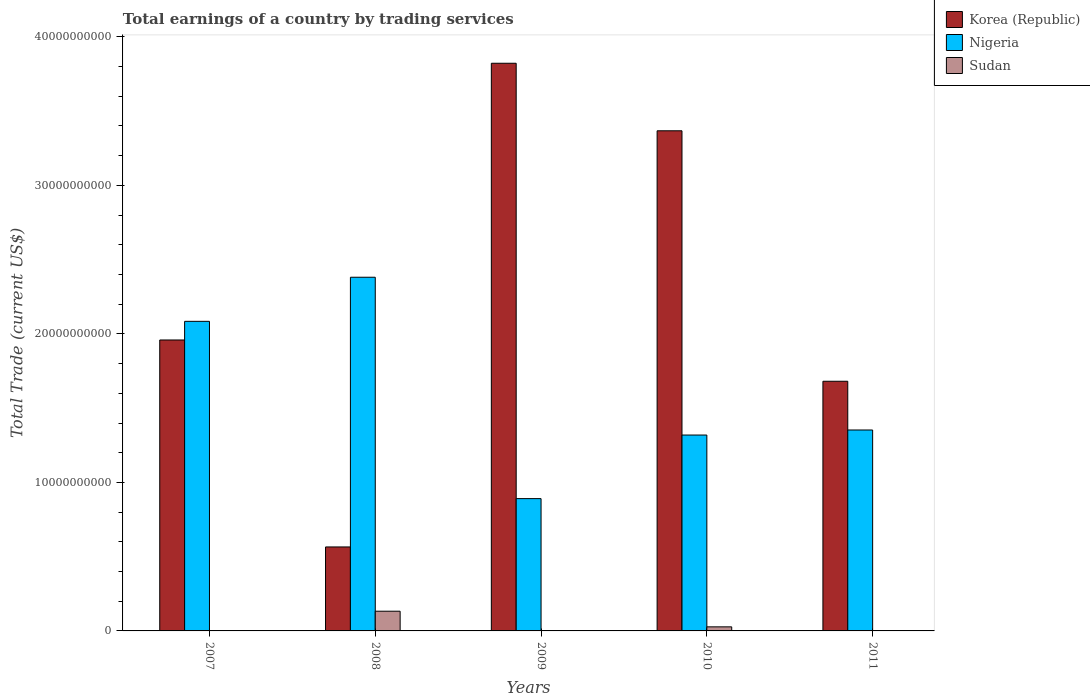How many groups of bars are there?
Your answer should be compact. 5. Are the number of bars on each tick of the X-axis equal?
Offer a terse response. No. How many bars are there on the 3rd tick from the left?
Your answer should be compact. 2. How many bars are there on the 1st tick from the right?
Your response must be concise. 3. In how many cases, is the number of bars for a given year not equal to the number of legend labels?
Your response must be concise. 2. What is the total earnings in Sudan in 2008?
Offer a very short reply. 1.33e+09. Across all years, what is the maximum total earnings in Nigeria?
Provide a short and direct response. 2.38e+1. Across all years, what is the minimum total earnings in Nigeria?
Make the answer very short. 8.91e+09. In which year was the total earnings in Korea (Republic) maximum?
Your response must be concise. 2009. What is the total total earnings in Nigeria in the graph?
Provide a succinct answer. 8.03e+1. What is the difference between the total earnings in Korea (Republic) in 2008 and that in 2010?
Offer a terse response. -2.80e+1. What is the difference between the total earnings in Nigeria in 2010 and the total earnings in Sudan in 2009?
Your response must be concise. 1.32e+1. What is the average total earnings in Sudan per year?
Your answer should be very brief. 3.25e+08. In the year 2008, what is the difference between the total earnings in Sudan and total earnings in Korea (Republic)?
Your answer should be compact. -4.33e+09. What is the ratio of the total earnings in Korea (Republic) in 2007 to that in 2008?
Your answer should be compact. 3.46. Is the total earnings in Sudan in 2008 less than that in 2010?
Give a very brief answer. No. Is the difference between the total earnings in Sudan in 2008 and 2010 greater than the difference between the total earnings in Korea (Republic) in 2008 and 2010?
Offer a terse response. Yes. What is the difference between the highest and the second highest total earnings in Korea (Republic)?
Your answer should be very brief. 4.55e+09. What is the difference between the highest and the lowest total earnings in Sudan?
Your answer should be very brief. 1.33e+09. In how many years, is the total earnings in Sudan greater than the average total earnings in Sudan taken over all years?
Provide a succinct answer. 1. Is the sum of the total earnings in Korea (Republic) in 2008 and 2009 greater than the maximum total earnings in Sudan across all years?
Offer a terse response. Yes. Is it the case that in every year, the sum of the total earnings in Sudan and total earnings in Nigeria is greater than the total earnings in Korea (Republic)?
Your response must be concise. No. Are all the bars in the graph horizontal?
Provide a short and direct response. No. How many years are there in the graph?
Ensure brevity in your answer.  5. What is the difference between two consecutive major ticks on the Y-axis?
Offer a terse response. 1.00e+1. Are the values on the major ticks of Y-axis written in scientific E-notation?
Offer a very short reply. No. Does the graph contain any zero values?
Your answer should be very brief. Yes. What is the title of the graph?
Make the answer very short. Total earnings of a country by trading services. What is the label or title of the X-axis?
Provide a succinct answer. Years. What is the label or title of the Y-axis?
Provide a short and direct response. Total Trade (current US$). What is the Total Trade (current US$) of Korea (Republic) in 2007?
Your response must be concise. 1.96e+1. What is the Total Trade (current US$) of Nigeria in 2007?
Your answer should be very brief. 2.08e+1. What is the Total Trade (current US$) of Korea (Republic) in 2008?
Offer a terse response. 5.65e+09. What is the Total Trade (current US$) in Nigeria in 2008?
Offer a terse response. 2.38e+1. What is the Total Trade (current US$) of Sudan in 2008?
Your response must be concise. 1.33e+09. What is the Total Trade (current US$) of Korea (Republic) in 2009?
Ensure brevity in your answer.  3.82e+1. What is the Total Trade (current US$) in Nigeria in 2009?
Offer a very short reply. 8.91e+09. What is the Total Trade (current US$) of Korea (Republic) in 2010?
Give a very brief answer. 3.37e+1. What is the Total Trade (current US$) in Nigeria in 2010?
Offer a very short reply. 1.32e+1. What is the Total Trade (current US$) in Sudan in 2010?
Provide a short and direct response. 2.74e+08. What is the Total Trade (current US$) in Korea (Republic) in 2011?
Give a very brief answer. 1.68e+1. What is the Total Trade (current US$) of Nigeria in 2011?
Your answer should be very brief. 1.35e+1. What is the Total Trade (current US$) in Sudan in 2011?
Offer a very short reply. 2.31e+07. Across all years, what is the maximum Total Trade (current US$) of Korea (Republic)?
Ensure brevity in your answer.  3.82e+1. Across all years, what is the maximum Total Trade (current US$) of Nigeria?
Ensure brevity in your answer.  2.38e+1. Across all years, what is the maximum Total Trade (current US$) in Sudan?
Provide a short and direct response. 1.33e+09. Across all years, what is the minimum Total Trade (current US$) of Korea (Republic)?
Provide a short and direct response. 5.65e+09. Across all years, what is the minimum Total Trade (current US$) of Nigeria?
Your answer should be compact. 8.91e+09. What is the total Total Trade (current US$) in Korea (Republic) in the graph?
Ensure brevity in your answer.  1.14e+11. What is the total Total Trade (current US$) of Nigeria in the graph?
Your answer should be very brief. 8.03e+1. What is the total Total Trade (current US$) of Sudan in the graph?
Keep it short and to the point. 1.62e+09. What is the difference between the Total Trade (current US$) of Korea (Republic) in 2007 and that in 2008?
Offer a very short reply. 1.39e+1. What is the difference between the Total Trade (current US$) of Nigeria in 2007 and that in 2008?
Provide a succinct answer. -2.97e+09. What is the difference between the Total Trade (current US$) in Korea (Republic) in 2007 and that in 2009?
Provide a short and direct response. -1.86e+1. What is the difference between the Total Trade (current US$) in Nigeria in 2007 and that in 2009?
Your response must be concise. 1.19e+1. What is the difference between the Total Trade (current US$) of Korea (Republic) in 2007 and that in 2010?
Your answer should be very brief. -1.41e+1. What is the difference between the Total Trade (current US$) of Nigeria in 2007 and that in 2010?
Make the answer very short. 7.66e+09. What is the difference between the Total Trade (current US$) of Korea (Republic) in 2007 and that in 2011?
Provide a short and direct response. 2.78e+09. What is the difference between the Total Trade (current US$) in Nigeria in 2007 and that in 2011?
Your answer should be very brief. 7.32e+09. What is the difference between the Total Trade (current US$) in Korea (Republic) in 2008 and that in 2009?
Your answer should be compact. -3.26e+1. What is the difference between the Total Trade (current US$) in Nigeria in 2008 and that in 2009?
Your response must be concise. 1.49e+1. What is the difference between the Total Trade (current US$) of Korea (Republic) in 2008 and that in 2010?
Your answer should be compact. -2.80e+1. What is the difference between the Total Trade (current US$) of Nigeria in 2008 and that in 2010?
Give a very brief answer. 1.06e+1. What is the difference between the Total Trade (current US$) in Sudan in 2008 and that in 2010?
Your response must be concise. 1.05e+09. What is the difference between the Total Trade (current US$) in Korea (Republic) in 2008 and that in 2011?
Make the answer very short. -1.12e+1. What is the difference between the Total Trade (current US$) of Nigeria in 2008 and that in 2011?
Offer a very short reply. 1.03e+1. What is the difference between the Total Trade (current US$) of Sudan in 2008 and that in 2011?
Offer a terse response. 1.30e+09. What is the difference between the Total Trade (current US$) of Korea (Republic) in 2009 and that in 2010?
Offer a very short reply. 4.55e+09. What is the difference between the Total Trade (current US$) of Nigeria in 2009 and that in 2010?
Your response must be concise. -4.28e+09. What is the difference between the Total Trade (current US$) in Korea (Republic) in 2009 and that in 2011?
Your answer should be compact. 2.14e+1. What is the difference between the Total Trade (current US$) of Nigeria in 2009 and that in 2011?
Your answer should be compact. -4.62e+09. What is the difference between the Total Trade (current US$) of Korea (Republic) in 2010 and that in 2011?
Keep it short and to the point. 1.69e+1. What is the difference between the Total Trade (current US$) of Nigeria in 2010 and that in 2011?
Offer a terse response. -3.40e+08. What is the difference between the Total Trade (current US$) of Sudan in 2010 and that in 2011?
Provide a succinct answer. 2.51e+08. What is the difference between the Total Trade (current US$) of Korea (Republic) in 2007 and the Total Trade (current US$) of Nigeria in 2008?
Give a very brief answer. -4.22e+09. What is the difference between the Total Trade (current US$) of Korea (Republic) in 2007 and the Total Trade (current US$) of Sudan in 2008?
Your answer should be very brief. 1.83e+1. What is the difference between the Total Trade (current US$) in Nigeria in 2007 and the Total Trade (current US$) in Sudan in 2008?
Provide a short and direct response. 1.95e+1. What is the difference between the Total Trade (current US$) of Korea (Republic) in 2007 and the Total Trade (current US$) of Nigeria in 2009?
Give a very brief answer. 1.07e+1. What is the difference between the Total Trade (current US$) of Korea (Republic) in 2007 and the Total Trade (current US$) of Nigeria in 2010?
Offer a terse response. 6.40e+09. What is the difference between the Total Trade (current US$) of Korea (Republic) in 2007 and the Total Trade (current US$) of Sudan in 2010?
Your answer should be compact. 1.93e+1. What is the difference between the Total Trade (current US$) in Nigeria in 2007 and the Total Trade (current US$) in Sudan in 2010?
Ensure brevity in your answer.  2.06e+1. What is the difference between the Total Trade (current US$) of Korea (Republic) in 2007 and the Total Trade (current US$) of Nigeria in 2011?
Keep it short and to the point. 6.06e+09. What is the difference between the Total Trade (current US$) of Korea (Republic) in 2007 and the Total Trade (current US$) of Sudan in 2011?
Make the answer very short. 1.96e+1. What is the difference between the Total Trade (current US$) in Nigeria in 2007 and the Total Trade (current US$) in Sudan in 2011?
Keep it short and to the point. 2.08e+1. What is the difference between the Total Trade (current US$) of Korea (Republic) in 2008 and the Total Trade (current US$) of Nigeria in 2009?
Ensure brevity in your answer.  -3.25e+09. What is the difference between the Total Trade (current US$) in Korea (Republic) in 2008 and the Total Trade (current US$) in Nigeria in 2010?
Provide a short and direct response. -7.53e+09. What is the difference between the Total Trade (current US$) of Korea (Republic) in 2008 and the Total Trade (current US$) of Sudan in 2010?
Give a very brief answer. 5.38e+09. What is the difference between the Total Trade (current US$) in Nigeria in 2008 and the Total Trade (current US$) in Sudan in 2010?
Your answer should be compact. 2.35e+1. What is the difference between the Total Trade (current US$) of Korea (Republic) in 2008 and the Total Trade (current US$) of Nigeria in 2011?
Make the answer very short. -7.88e+09. What is the difference between the Total Trade (current US$) of Korea (Republic) in 2008 and the Total Trade (current US$) of Sudan in 2011?
Give a very brief answer. 5.63e+09. What is the difference between the Total Trade (current US$) of Nigeria in 2008 and the Total Trade (current US$) of Sudan in 2011?
Offer a terse response. 2.38e+1. What is the difference between the Total Trade (current US$) in Korea (Republic) in 2009 and the Total Trade (current US$) in Nigeria in 2010?
Make the answer very short. 2.50e+1. What is the difference between the Total Trade (current US$) in Korea (Republic) in 2009 and the Total Trade (current US$) in Sudan in 2010?
Provide a short and direct response. 3.79e+1. What is the difference between the Total Trade (current US$) in Nigeria in 2009 and the Total Trade (current US$) in Sudan in 2010?
Keep it short and to the point. 8.63e+09. What is the difference between the Total Trade (current US$) in Korea (Republic) in 2009 and the Total Trade (current US$) in Nigeria in 2011?
Give a very brief answer. 2.47e+1. What is the difference between the Total Trade (current US$) of Korea (Republic) in 2009 and the Total Trade (current US$) of Sudan in 2011?
Your answer should be compact. 3.82e+1. What is the difference between the Total Trade (current US$) of Nigeria in 2009 and the Total Trade (current US$) of Sudan in 2011?
Your response must be concise. 8.89e+09. What is the difference between the Total Trade (current US$) of Korea (Republic) in 2010 and the Total Trade (current US$) of Nigeria in 2011?
Your answer should be very brief. 2.01e+1. What is the difference between the Total Trade (current US$) of Korea (Republic) in 2010 and the Total Trade (current US$) of Sudan in 2011?
Your answer should be compact. 3.37e+1. What is the difference between the Total Trade (current US$) of Nigeria in 2010 and the Total Trade (current US$) of Sudan in 2011?
Ensure brevity in your answer.  1.32e+1. What is the average Total Trade (current US$) of Korea (Republic) per year?
Give a very brief answer. 2.28e+1. What is the average Total Trade (current US$) in Nigeria per year?
Give a very brief answer. 1.61e+1. What is the average Total Trade (current US$) in Sudan per year?
Keep it short and to the point. 3.25e+08. In the year 2007, what is the difference between the Total Trade (current US$) of Korea (Republic) and Total Trade (current US$) of Nigeria?
Make the answer very short. -1.26e+09. In the year 2008, what is the difference between the Total Trade (current US$) in Korea (Republic) and Total Trade (current US$) in Nigeria?
Provide a succinct answer. -1.82e+1. In the year 2008, what is the difference between the Total Trade (current US$) in Korea (Republic) and Total Trade (current US$) in Sudan?
Keep it short and to the point. 4.33e+09. In the year 2008, what is the difference between the Total Trade (current US$) in Nigeria and Total Trade (current US$) in Sudan?
Your response must be concise. 2.25e+1. In the year 2009, what is the difference between the Total Trade (current US$) of Korea (Republic) and Total Trade (current US$) of Nigeria?
Give a very brief answer. 2.93e+1. In the year 2010, what is the difference between the Total Trade (current US$) in Korea (Republic) and Total Trade (current US$) in Nigeria?
Your answer should be compact. 2.05e+1. In the year 2010, what is the difference between the Total Trade (current US$) of Korea (Republic) and Total Trade (current US$) of Sudan?
Your answer should be compact. 3.34e+1. In the year 2010, what is the difference between the Total Trade (current US$) in Nigeria and Total Trade (current US$) in Sudan?
Ensure brevity in your answer.  1.29e+1. In the year 2011, what is the difference between the Total Trade (current US$) of Korea (Republic) and Total Trade (current US$) of Nigeria?
Ensure brevity in your answer.  3.28e+09. In the year 2011, what is the difference between the Total Trade (current US$) of Korea (Republic) and Total Trade (current US$) of Sudan?
Ensure brevity in your answer.  1.68e+1. In the year 2011, what is the difference between the Total Trade (current US$) in Nigeria and Total Trade (current US$) in Sudan?
Your answer should be compact. 1.35e+1. What is the ratio of the Total Trade (current US$) in Korea (Republic) in 2007 to that in 2008?
Offer a terse response. 3.46. What is the ratio of the Total Trade (current US$) of Nigeria in 2007 to that in 2008?
Keep it short and to the point. 0.88. What is the ratio of the Total Trade (current US$) of Korea (Republic) in 2007 to that in 2009?
Provide a short and direct response. 0.51. What is the ratio of the Total Trade (current US$) of Nigeria in 2007 to that in 2009?
Your response must be concise. 2.34. What is the ratio of the Total Trade (current US$) of Korea (Republic) in 2007 to that in 2010?
Make the answer very short. 0.58. What is the ratio of the Total Trade (current US$) of Nigeria in 2007 to that in 2010?
Provide a short and direct response. 1.58. What is the ratio of the Total Trade (current US$) of Korea (Republic) in 2007 to that in 2011?
Keep it short and to the point. 1.17. What is the ratio of the Total Trade (current US$) in Nigeria in 2007 to that in 2011?
Your answer should be compact. 1.54. What is the ratio of the Total Trade (current US$) of Korea (Republic) in 2008 to that in 2009?
Keep it short and to the point. 0.15. What is the ratio of the Total Trade (current US$) of Nigeria in 2008 to that in 2009?
Give a very brief answer. 2.67. What is the ratio of the Total Trade (current US$) in Korea (Republic) in 2008 to that in 2010?
Your answer should be compact. 0.17. What is the ratio of the Total Trade (current US$) of Nigeria in 2008 to that in 2010?
Keep it short and to the point. 1.81. What is the ratio of the Total Trade (current US$) in Sudan in 2008 to that in 2010?
Your answer should be very brief. 4.83. What is the ratio of the Total Trade (current US$) of Korea (Republic) in 2008 to that in 2011?
Make the answer very short. 0.34. What is the ratio of the Total Trade (current US$) in Nigeria in 2008 to that in 2011?
Provide a succinct answer. 1.76. What is the ratio of the Total Trade (current US$) of Sudan in 2008 to that in 2011?
Give a very brief answer. 57.38. What is the ratio of the Total Trade (current US$) in Korea (Republic) in 2009 to that in 2010?
Your answer should be compact. 1.14. What is the ratio of the Total Trade (current US$) in Nigeria in 2009 to that in 2010?
Give a very brief answer. 0.68. What is the ratio of the Total Trade (current US$) in Korea (Republic) in 2009 to that in 2011?
Keep it short and to the point. 2.27. What is the ratio of the Total Trade (current US$) in Nigeria in 2009 to that in 2011?
Offer a terse response. 0.66. What is the ratio of the Total Trade (current US$) in Korea (Republic) in 2010 to that in 2011?
Your answer should be compact. 2. What is the ratio of the Total Trade (current US$) in Nigeria in 2010 to that in 2011?
Keep it short and to the point. 0.97. What is the ratio of the Total Trade (current US$) of Sudan in 2010 to that in 2011?
Your answer should be very brief. 11.87. What is the difference between the highest and the second highest Total Trade (current US$) in Korea (Republic)?
Your response must be concise. 4.55e+09. What is the difference between the highest and the second highest Total Trade (current US$) of Nigeria?
Your response must be concise. 2.97e+09. What is the difference between the highest and the second highest Total Trade (current US$) in Sudan?
Ensure brevity in your answer.  1.05e+09. What is the difference between the highest and the lowest Total Trade (current US$) in Korea (Republic)?
Make the answer very short. 3.26e+1. What is the difference between the highest and the lowest Total Trade (current US$) of Nigeria?
Offer a very short reply. 1.49e+1. What is the difference between the highest and the lowest Total Trade (current US$) in Sudan?
Provide a succinct answer. 1.33e+09. 